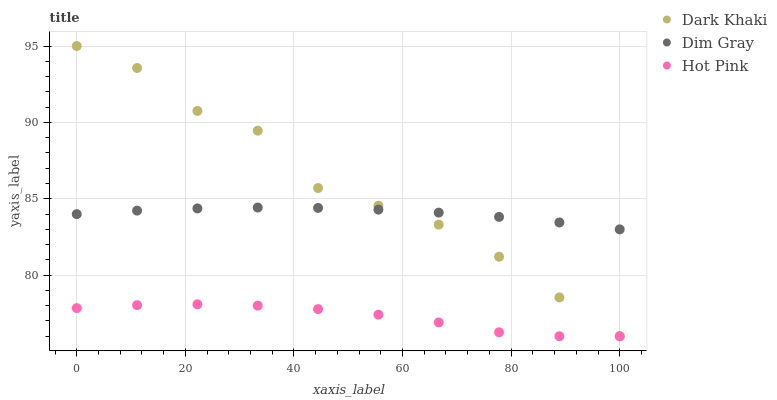Does Hot Pink have the minimum area under the curve?
Answer yes or no. Yes. Does Dark Khaki have the maximum area under the curve?
Answer yes or no. Yes. Does Dim Gray have the minimum area under the curve?
Answer yes or no. No. Does Dim Gray have the maximum area under the curve?
Answer yes or no. No. Is Dim Gray the smoothest?
Answer yes or no. Yes. Is Dark Khaki the roughest?
Answer yes or no. Yes. Is Hot Pink the smoothest?
Answer yes or no. No. Is Hot Pink the roughest?
Answer yes or no. No. Does Dark Khaki have the lowest value?
Answer yes or no. Yes. Does Dim Gray have the lowest value?
Answer yes or no. No. Does Dark Khaki have the highest value?
Answer yes or no. Yes. Does Dim Gray have the highest value?
Answer yes or no. No. Is Hot Pink less than Dim Gray?
Answer yes or no. Yes. Is Dim Gray greater than Hot Pink?
Answer yes or no. Yes. Does Dark Khaki intersect Dim Gray?
Answer yes or no. Yes. Is Dark Khaki less than Dim Gray?
Answer yes or no. No. Is Dark Khaki greater than Dim Gray?
Answer yes or no. No. Does Hot Pink intersect Dim Gray?
Answer yes or no. No. 